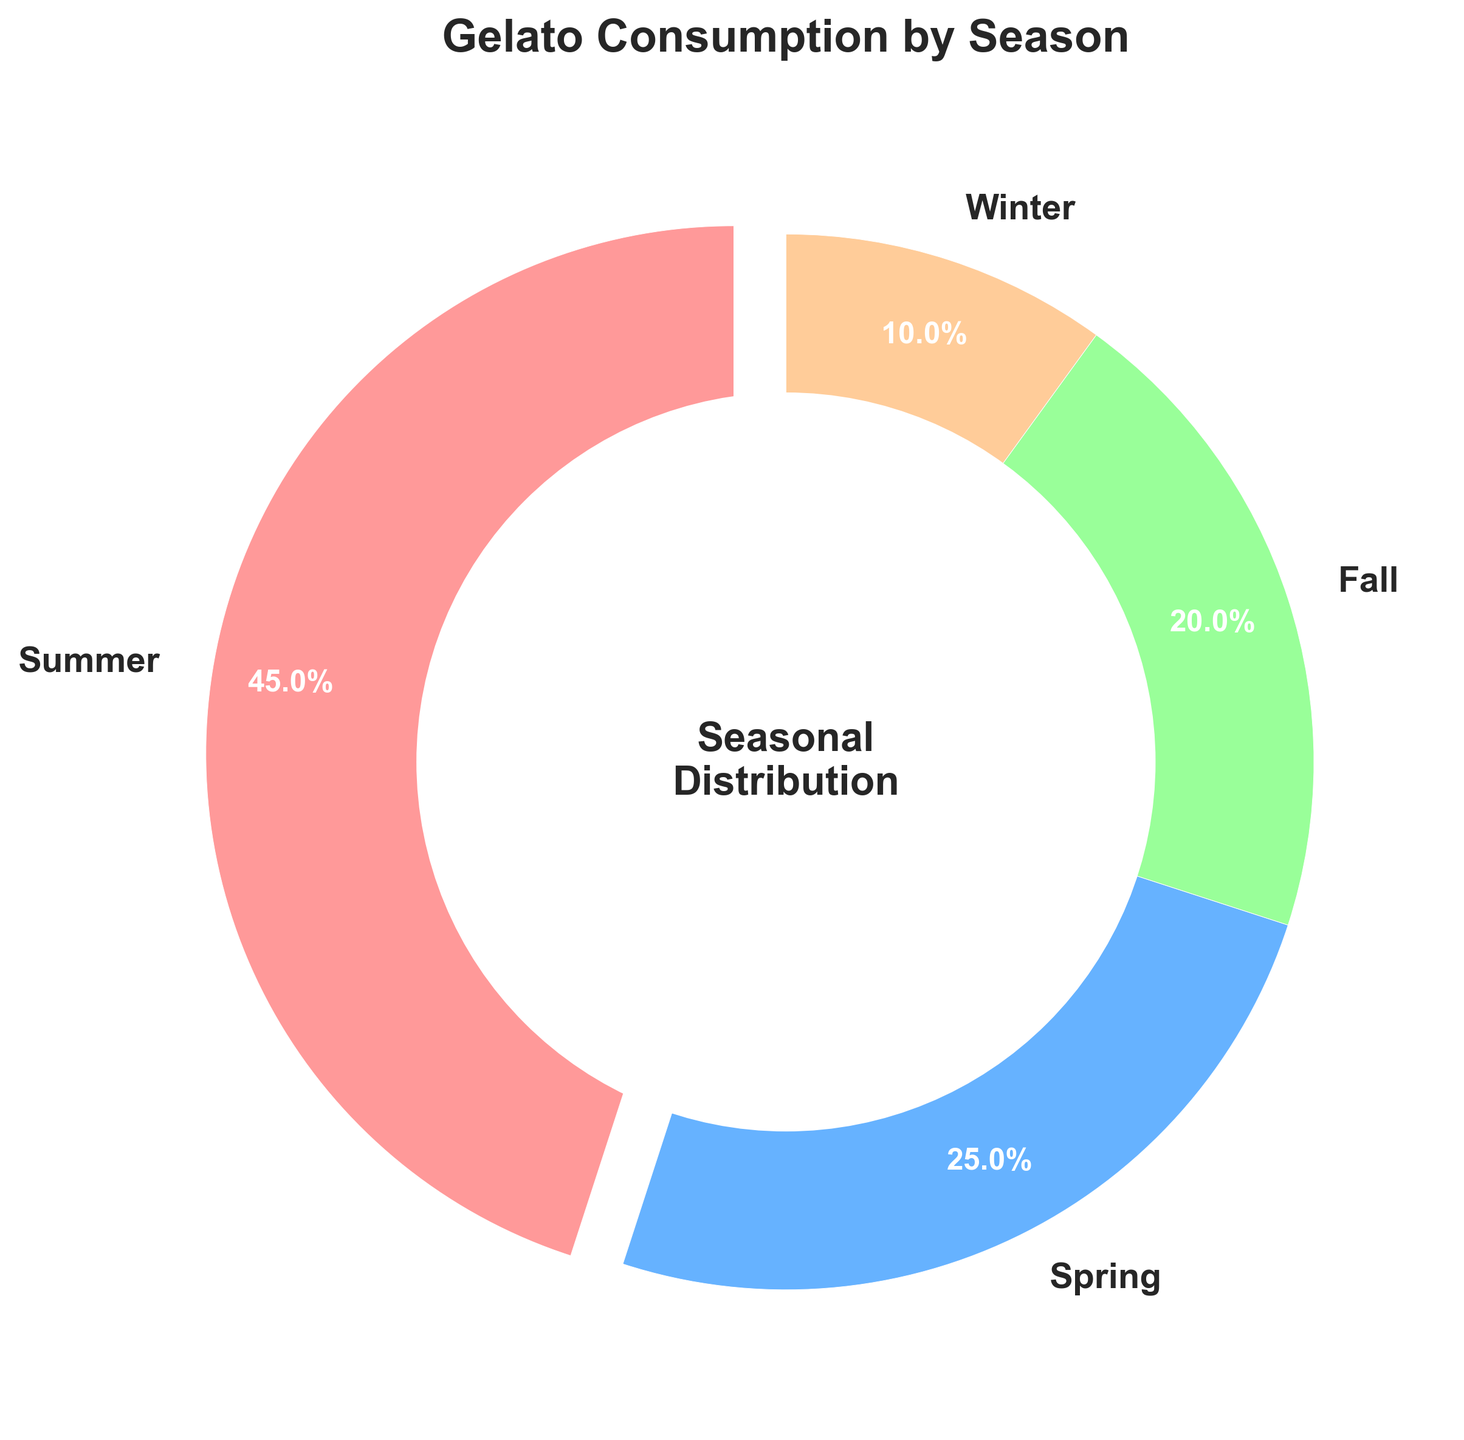What percentage of gelato consumption occurs in summer and spring combined? Summing up the percentages of gelato consumption in summer and spring, which are 45% and 25%, respectively, we get 45 + 25 = 70. Thus, 70% of gelato consumption occurs in summer and spring combined.
Answer: 70% Is gelato consumption higher in fall or spring? Comparing the percentages, we see that fall has a consumption of 20% whereas spring has 25%. Thus, spring has higher gelato consumption than fall.
Answer: Spring What season has the lowest percentage of gelato consumption, and what is that percentage? Observing all the percentages in the chart, winter has the lowest percentage at 10%.
Answer: Winter, 10% What's the difference in gelato consumption percentages between the season with the highest and the lowest consumption? Summer has the highest consumption at 45% and winter the lowest at 10%. The difference is calculated as 45 - 10 = 35.
Answer: 35% What is the visual attribute used to highlight the season with the highest gelato consumption? The season with the highest consumption, summer, is accentuated by being 'exploded' or pulled out slightly from the pie chart for emphasis.
Answer: The slice is exploded How does gelato consumption in winter compare to that in fall? Winter's consumption is 10% while fall's is 20%. Therefore, gelato consumption in winter is half of that in fall.
Answer: Winter's consumption is half of fall's Which seasons contribute to less than half of the total gelato consumption? Adding up the percentages for spring, fall, and winter (25%, 20%, and 10%), we see that they contribute a total of 55%. However, we are interested in identifying each individually: fall (20%) and winter (10%).
Answer: Fall and Winter What percentage of gelato is consumed in non-summer seasons? Adding up the percentages for spring, fall, and winter, which are 25%, 20%, and 10%, respectively, gives us 25 + 20 + 10 = 55. Thus, 55% of gelato is consumed in non-summer seasons.
Answer: 55% If the total gelato consumption were 1000 liters, approximately how many liters would be consumed in spring? Given that spring accounts for 25% of the total consumption, 25% of 1000 liters is calculated as (25/100) * 1000 = 250 liters.
Answer: 250 liters 